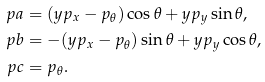Convert formula to latex. <formula><loc_0><loc_0><loc_500><loc_500>\ p a & = ( y p _ { x } - p _ { \theta } ) \cos \theta + y p _ { y } \sin \theta , \\ \ p b & = - ( y p _ { x } - p _ { \theta } ) \sin \theta + y p _ { y } \cos \theta , \\ \ p c & = p _ { \theta } .</formula> 